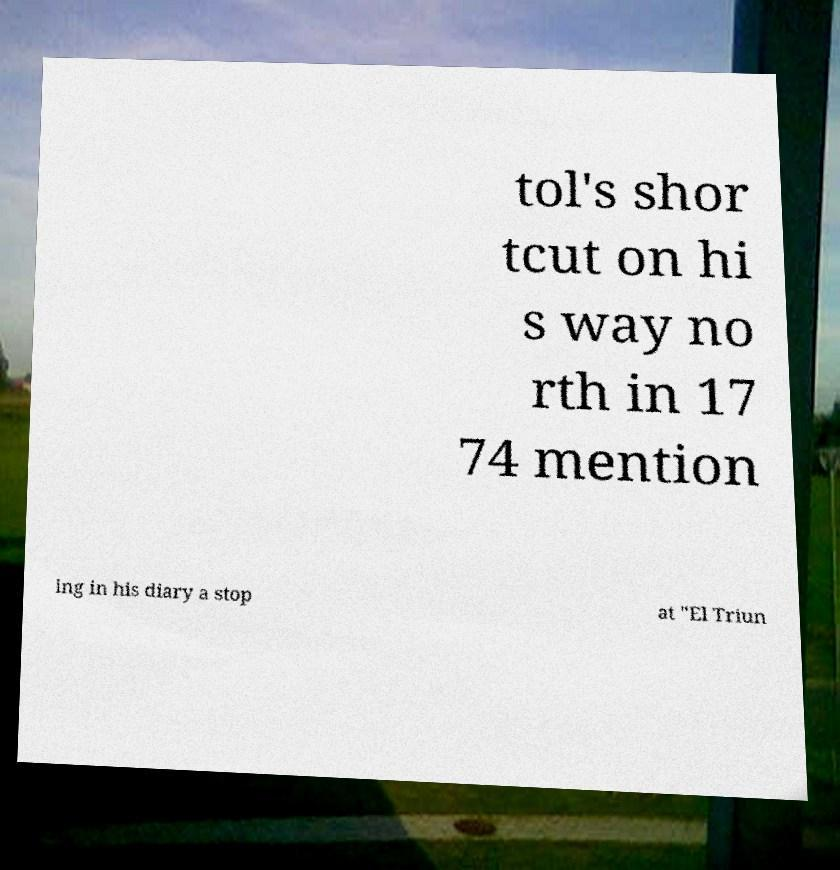For documentation purposes, I need the text within this image transcribed. Could you provide that? tol's shor tcut on hi s way no rth in 17 74 mention ing in his diary a stop at "El Triun 